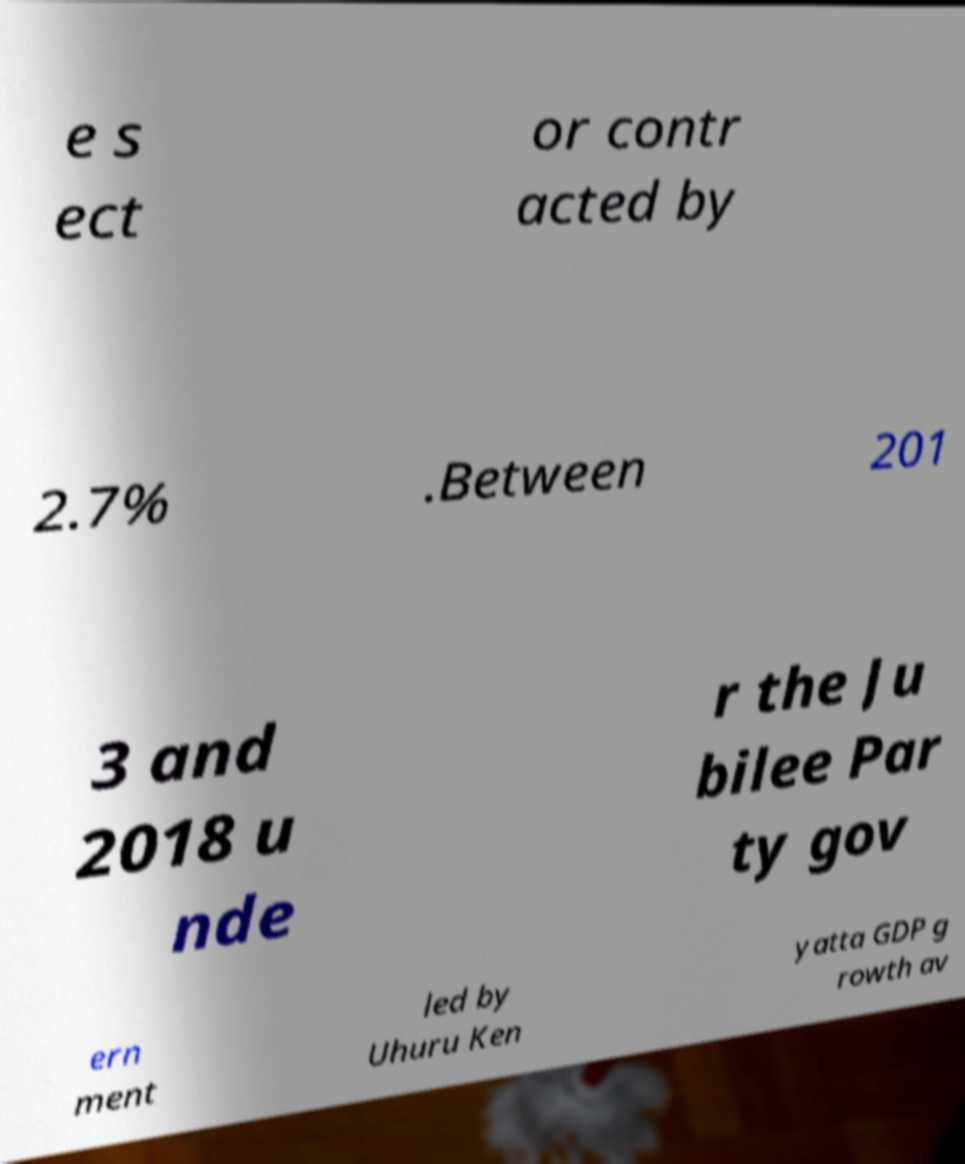There's text embedded in this image that I need extracted. Can you transcribe it verbatim? e s ect or contr acted by 2.7% .Between 201 3 and 2018 u nde r the Ju bilee Par ty gov ern ment led by Uhuru Ken yatta GDP g rowth av 